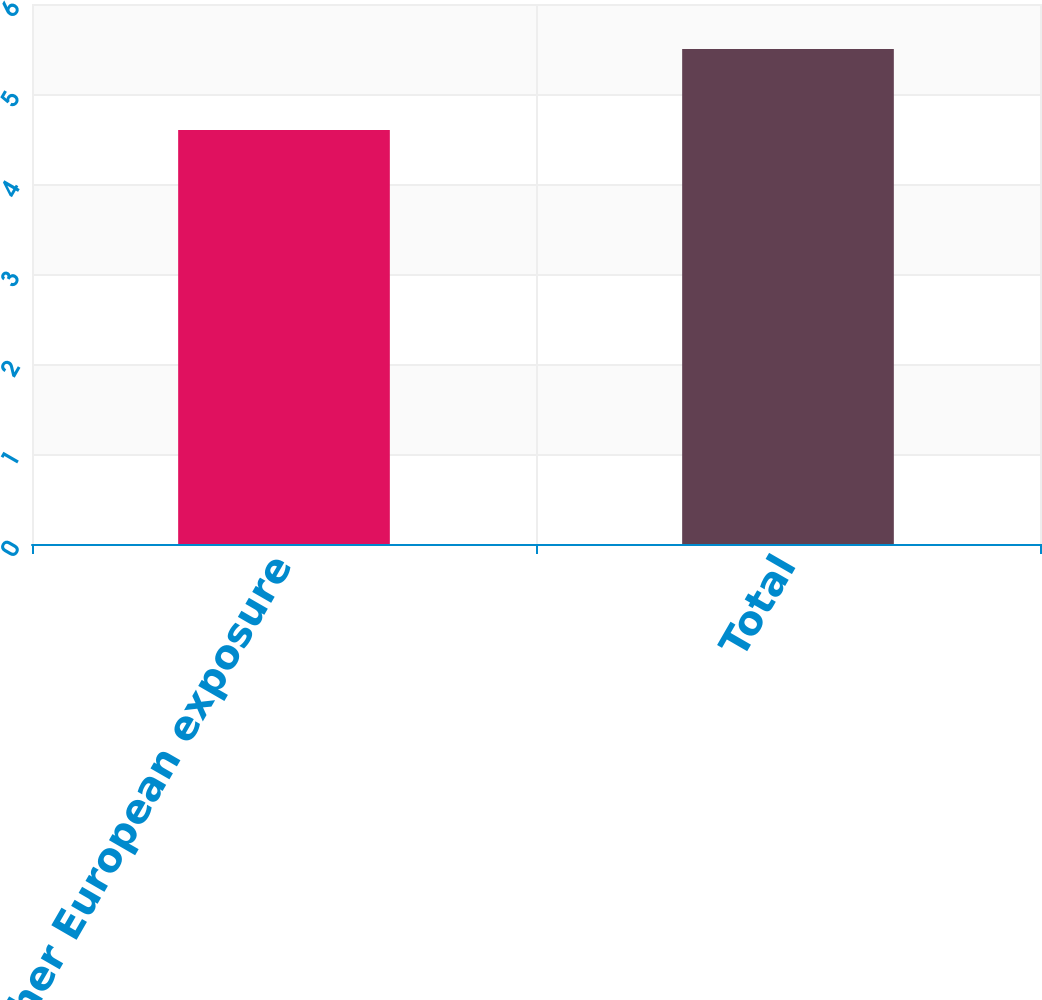Convert chart to OTSL. <chart><loc_0><loc_0><loc_500><loc_500><bar_chart><fcel>Other European exposure<fcel>Total<nl><fcel>4.6<fcel>5.5<nl></chart> 